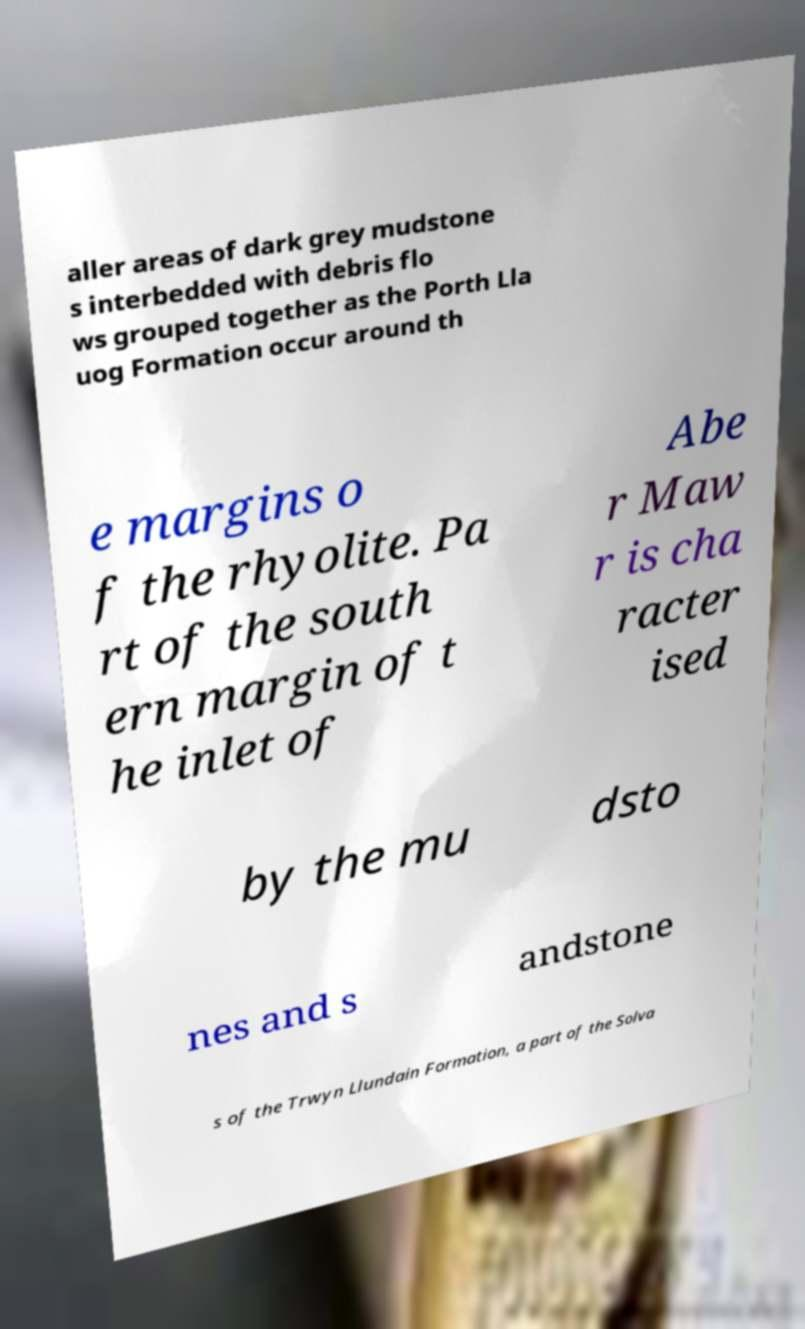Please identify and transcribe the text found in this image. aller areas of dark grey mudstone s interbedded with debris flo ws grouped together as the Porth Lla uog Formation occur around th e margins o f the rhyolite. Pa rt of the south ern margin of t he inlet of Abe r Maw r is cha racter ised by the mu dsto nes and s andstone s of the Trwyn Llundain Formation, a part of the Solva 